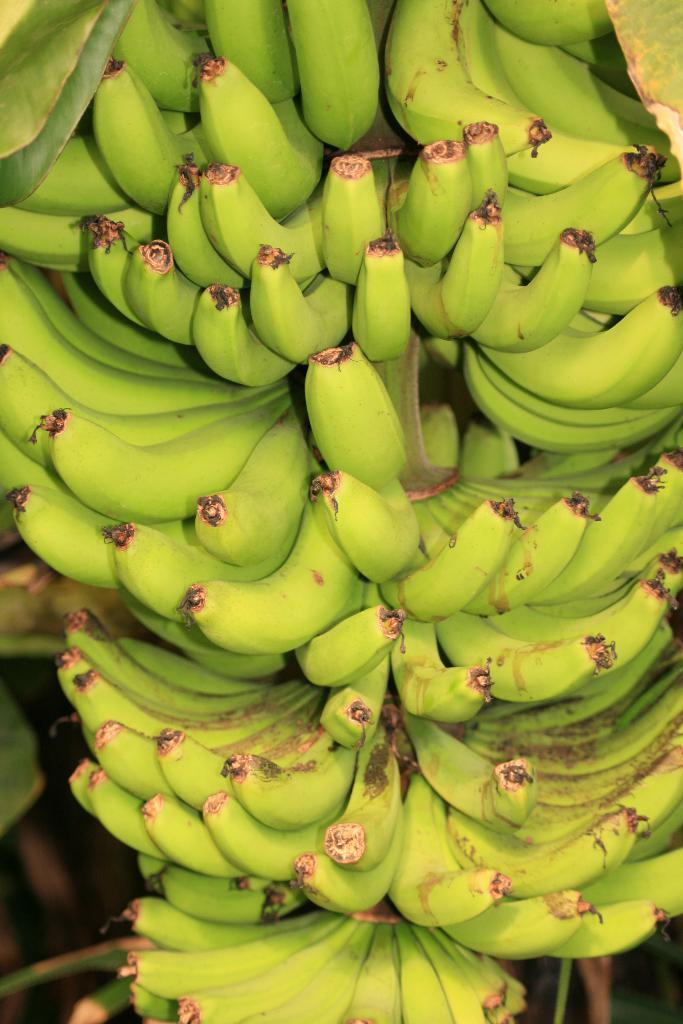What type of fruit is visible in the image? There are bananas in the image. What kind of trouble do the bananas cause in the image? There is no indication of trouble or any negative consequences related to the bananas in the image. 